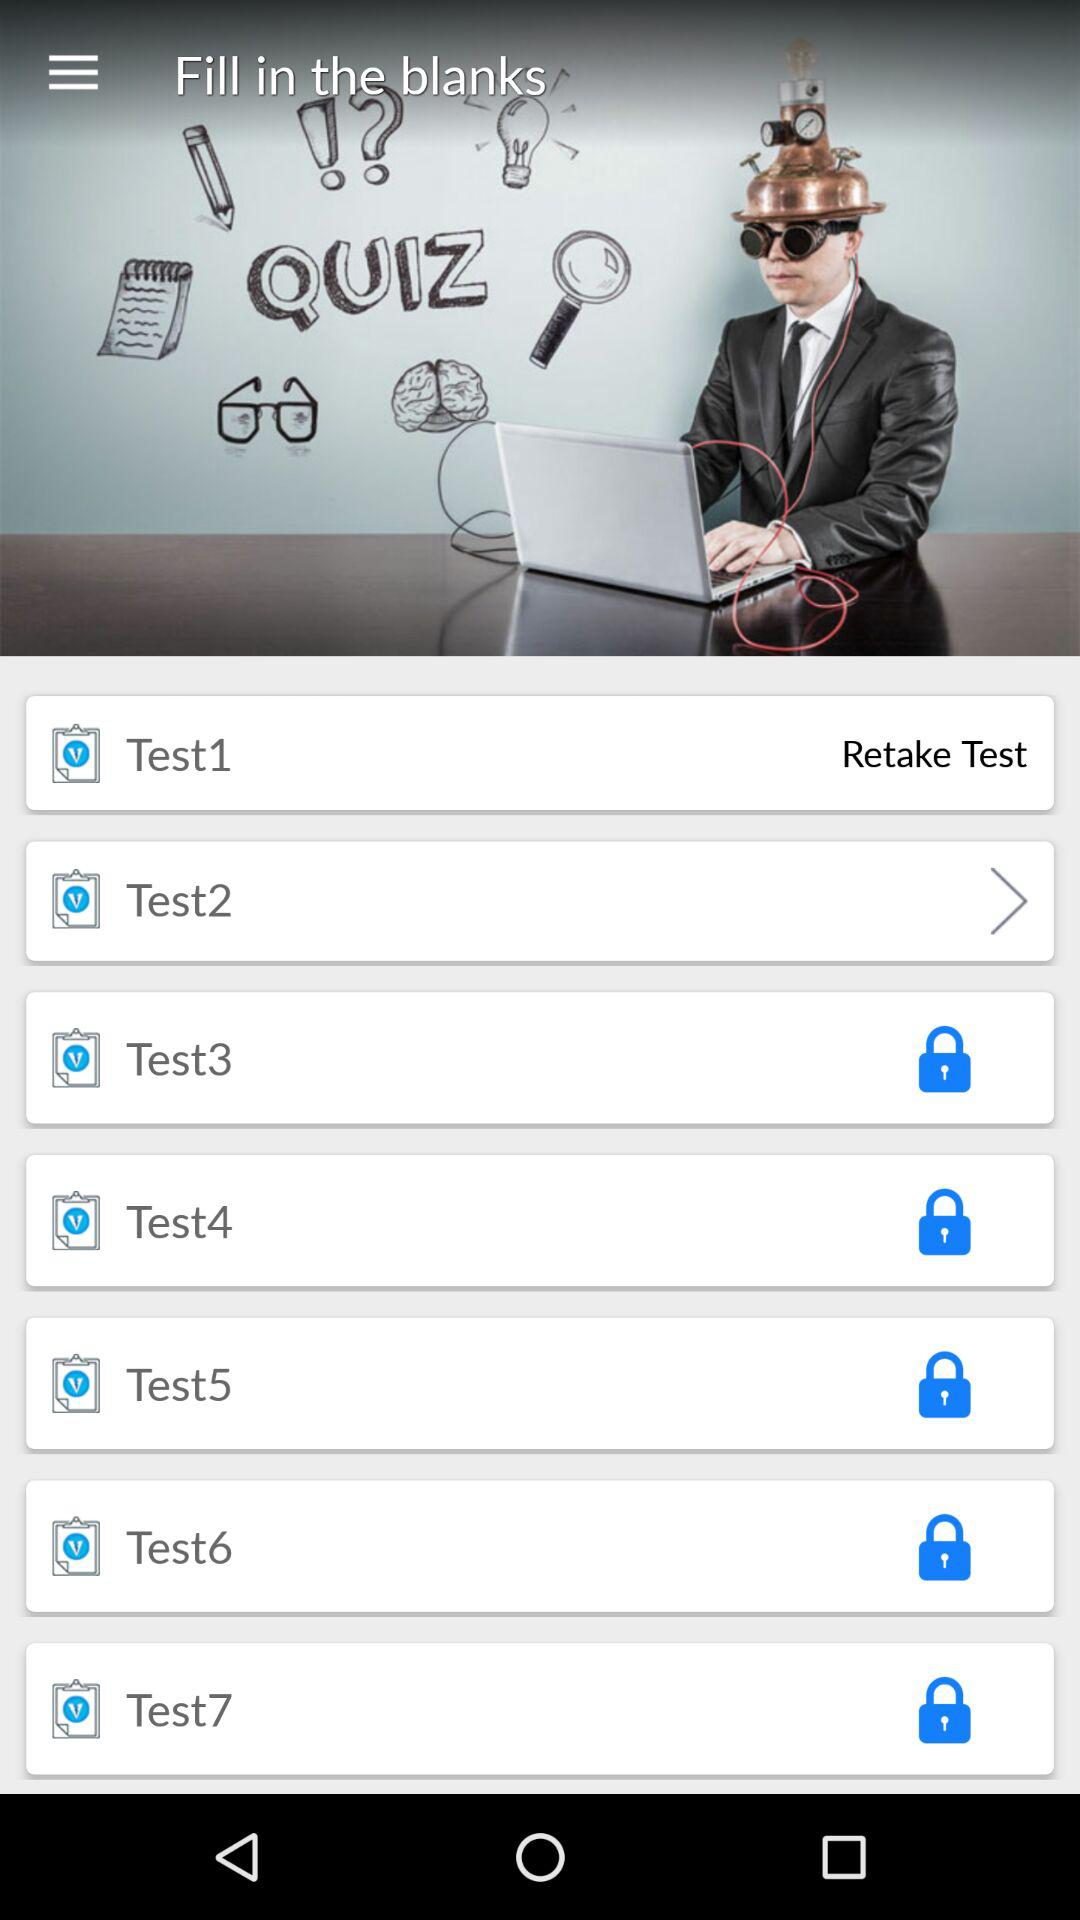Which test is going on?
When the provided information is insufficient, respond with <no answer>. <no answer> 